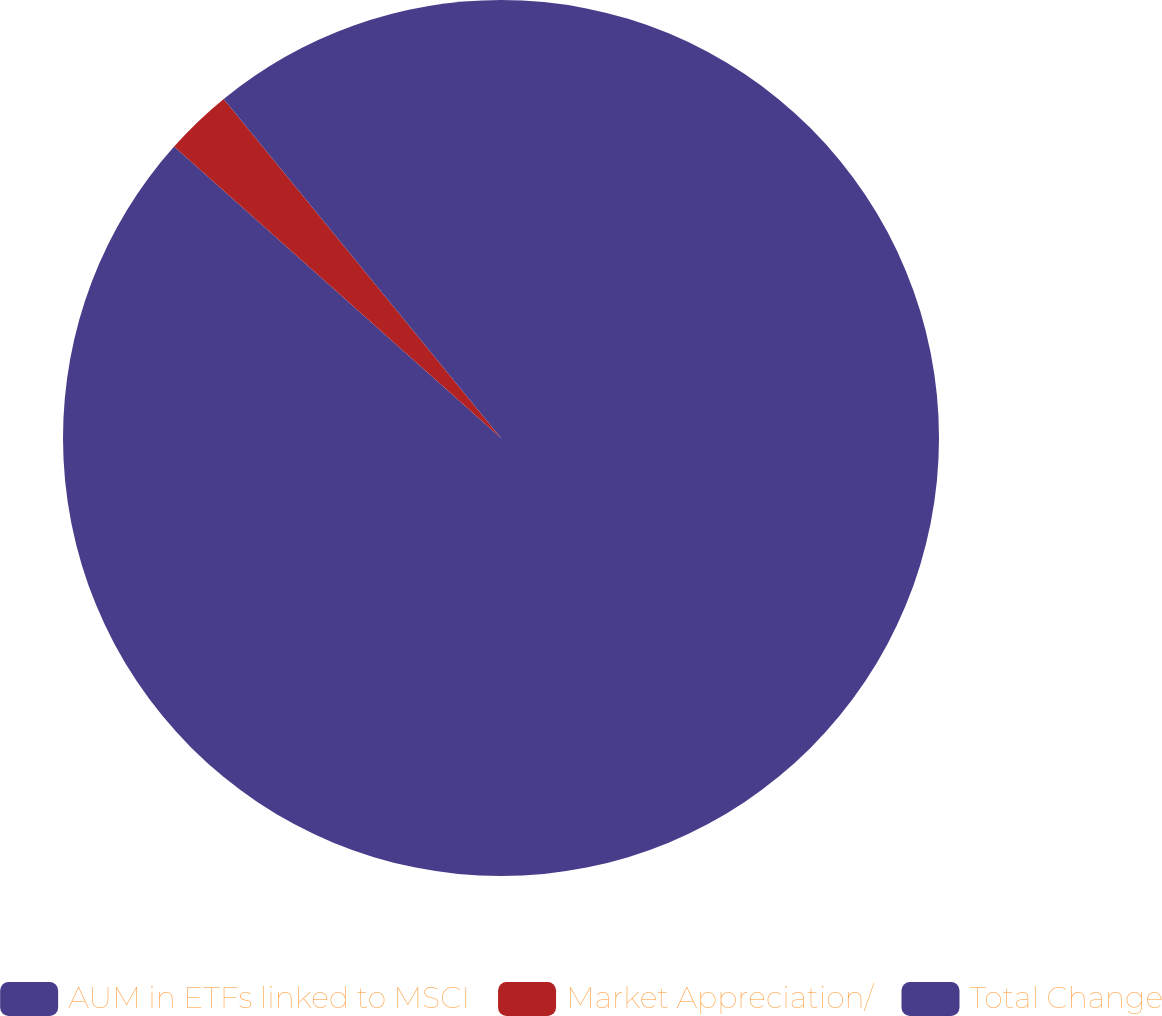<chart> <loc_0><loc_0><loc_500><loc_500><pie_chart><fcel>AUM in ETFs linked to MSCI<fcel>Market Appreciation/<fcel>Total Change<nl><fcel>86.59%<fcel>2.5%<fcel>10.91%<nl></chart> 